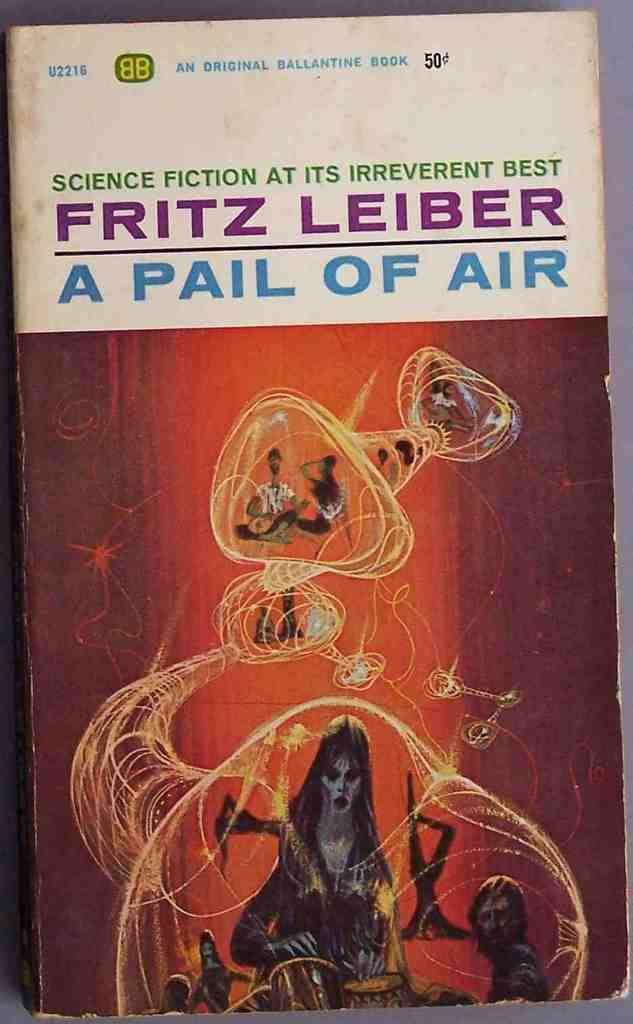What is the title of the book?
Ensure brevity in your answer.  A pail of air. Who is the author?
Offer a terse response. Fritz leiber. 